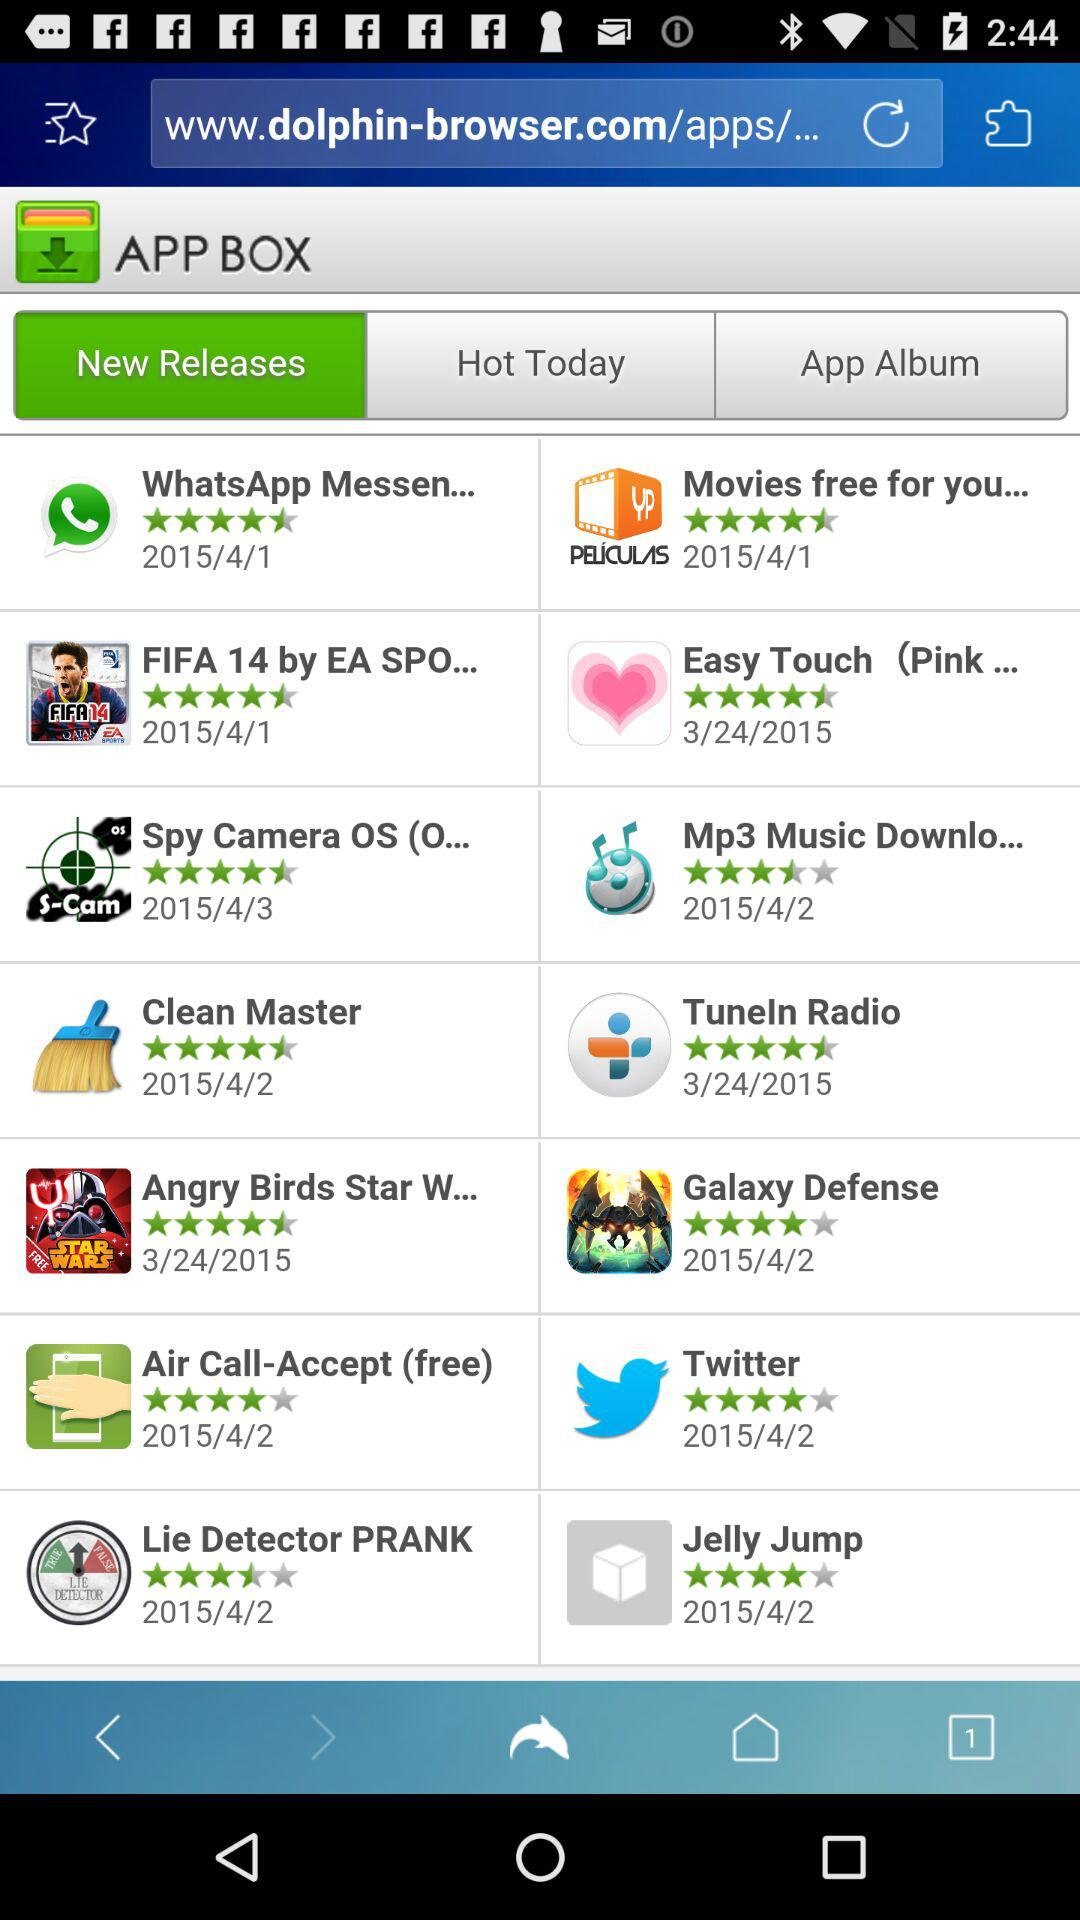What is the rating of Clean Master? The rating is 4.5 stars. 